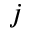<formula> <loc_0><loc_0><loc_500><loc_500>j</formula> 